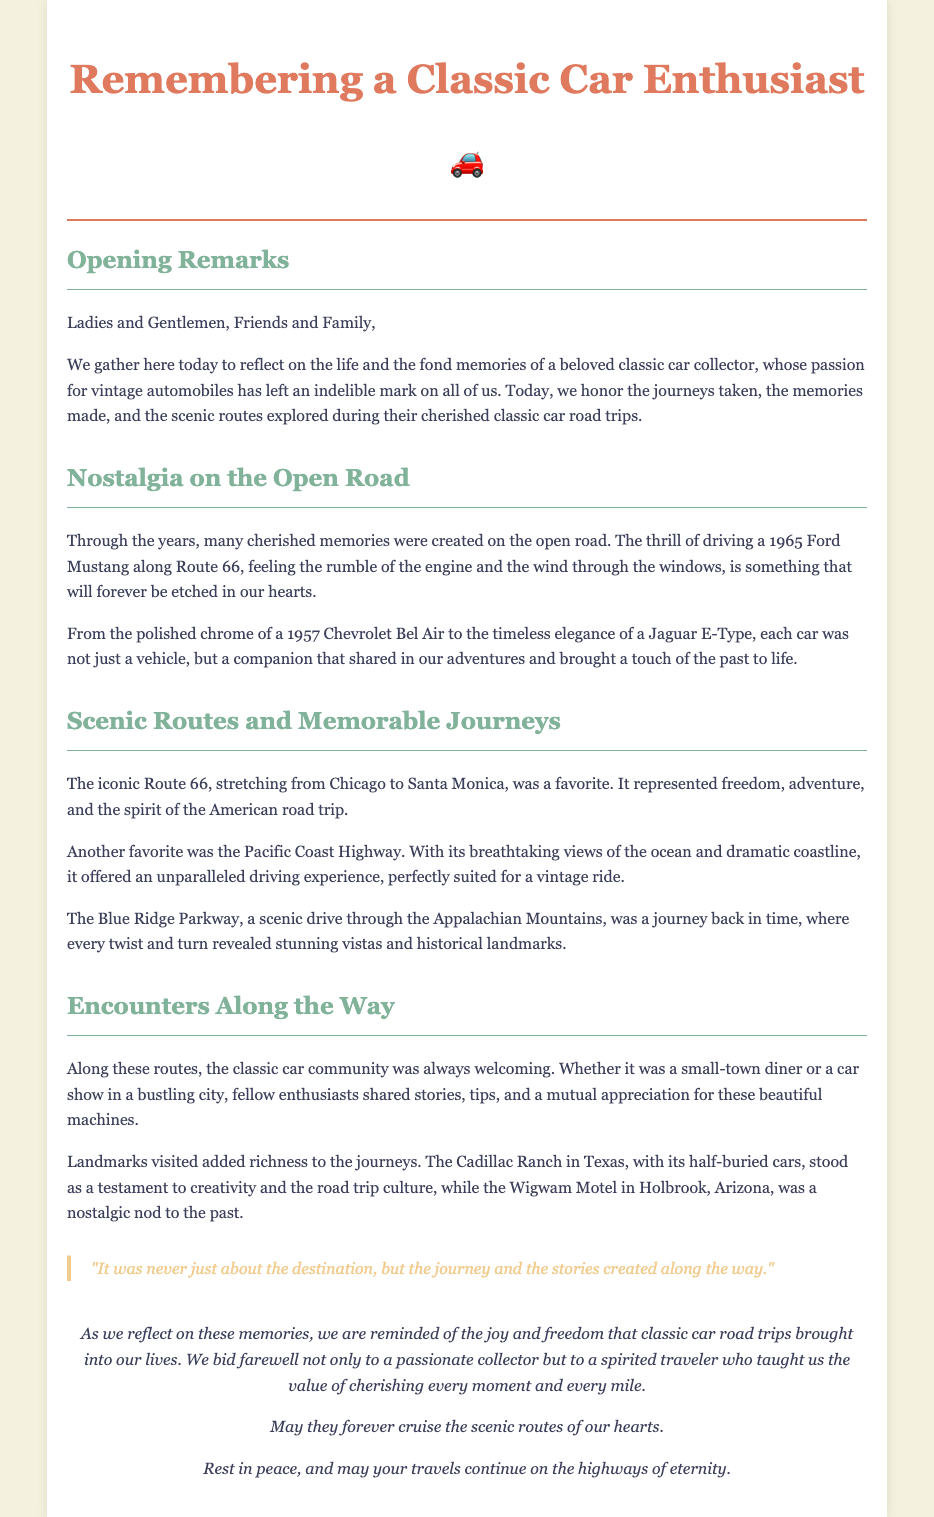What is the title of the document? The title is found in the header section of the document, which is "A Tribute to a Classic Car Enthusiast."
Answer: A Tribute to a Classic Car Enthusiast What iconic road was mentioned as a favorite? The document mentions Route 66 as a favorite scenic route in the section discussing memorable journeys.
Answer: Route 66 Which vintage car is described with polished chrome? The 1957 Chevrolet Bel Air is specifically mentioned as having polished chrome in the nostalgia section.
Answer: 1957 Chevrolet Bel Air What do the journeys remind us of, according to the closing section? The closing section emphasizes remembering the joy and freedom that classic car road trips brought into our lives.
Answer: Joy and freedom What landmark in Texas is referenced in the document? The Cadillac Ranch in Texas is mentioned as a landmark visited during the journeys.
Answer: Cadillac Ranch What does the quote emphasize according to the document? The quote highlights that it was never just about the destination, but the journey and stories created along the way.
Answer: The journey and stories How is the car community described in the document? The classic car community is described as always welcoming and friendly along the scenic routes.
Answer: Welcoming What type of vintage car is mentioned along with the Jaguar E-Type? The document refers to a 1965 Ford Mustang being driven along Route 66, alongside the Jaguar E-Type.
Answer: 1965 Ford Mustang 